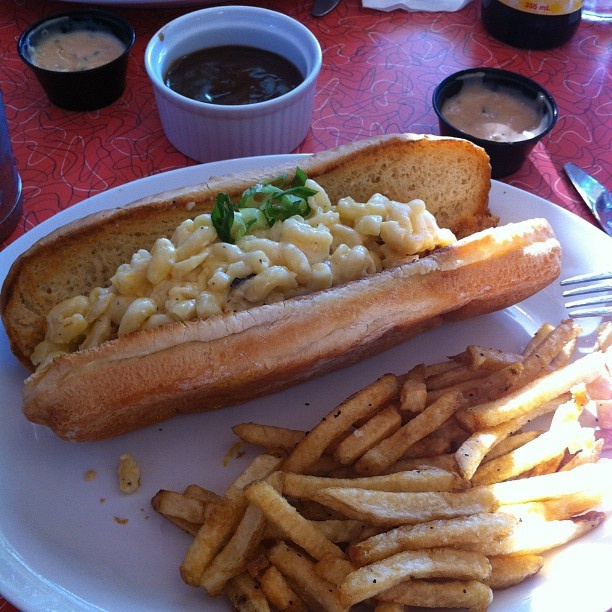Describe the objects in this image and their specific colors. I can see dining table in maroon, brown, gray, and black tones, sandwich in black, gray, maroon, and darkgray tones, bowl in black, gray, and purple tones, bowl in black, gray, and navy tones, and bowl in black, gray, and navy tones in this image. 